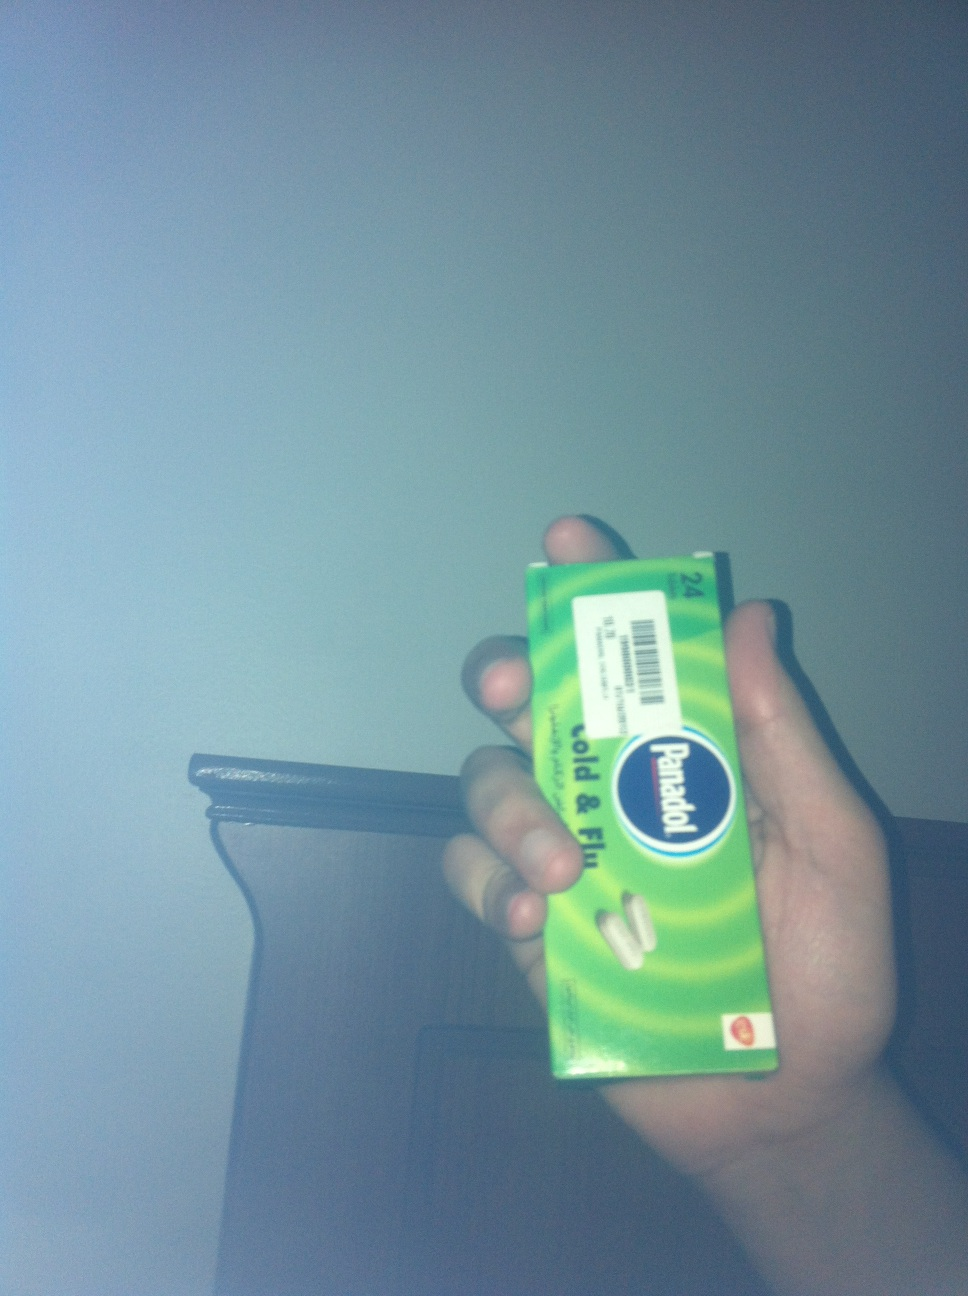Can you tell me more about the use of this medication? Panadol Cold & Flu is an over-the-counter medication designed to combat symptoms of the cold and flu. It usually contains ingredients like paracetamol to reduce fever and alleviate pain, as well as other components that may help with congestion. Always check the specific ingredients and consult with a healthcare provider for personal advisements. 